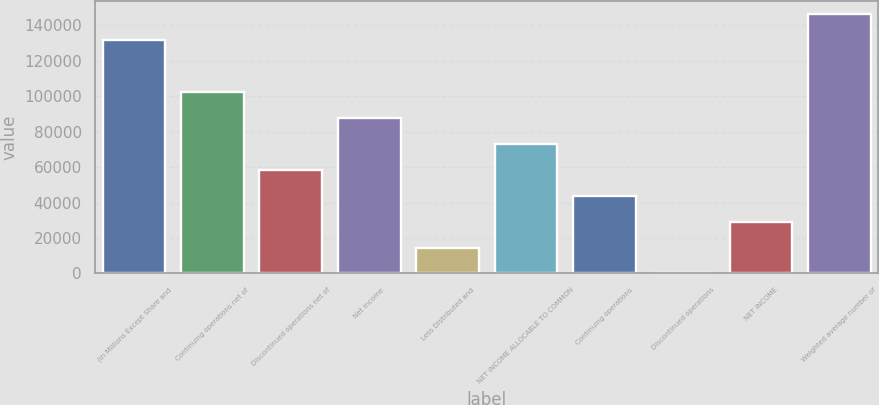Convert chart. <chart><loc_0><loc_0><loc_500><loc_500><bar_chart><fcel>(in Millions Except Share and<fcel>Continuing operations net of<fcel>Discontinued operations net of<fcel>Net income<fcel>Less Distributed and<fcel>NET INCOME ALLOCABLE TO COMMON<fcel>Continuing operations<fcel>Discontinued operations<fcel>NET INCOME<fcel>Weighted average number of<nl><fcel>131544<fcel>102312<fcel>58464.2<fcel>87696.1<fcel>14616.2<fcel>73080.1<fcel>43848.2<fcel>0.23<fcel>29232.2<fcel>146160<nl></chart> 